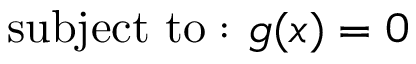Convert formula to latex. <formula><loc_0><loc_0><loc_500><loc_500>{ s u b j e c t t o \colon } \ g ( x ) = 0</formula> 